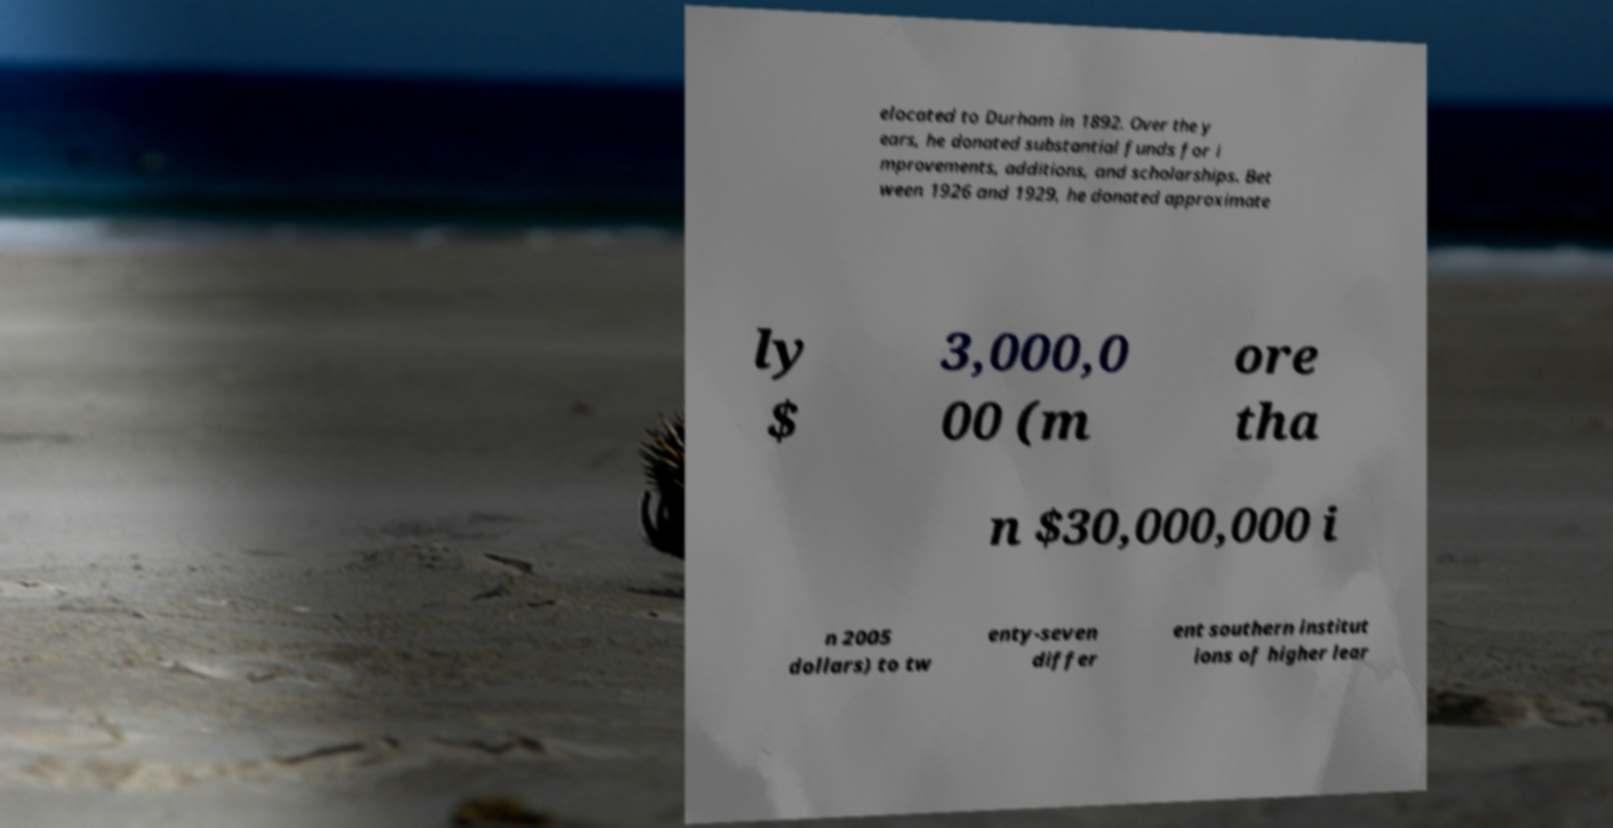I need the written content from this picture converted into text. Can you do that? elocated to Durham in 1892. Over the y ears, he donated substantial funds for i mprovements, additions, and scholarships. Bet ween 1926 and 1929, he donated approximate ly $ 3,000,0 00 (m ore tha n $30,000,000 i n 2005 dollars) to tw enty-seven differ ent southern institut ions of higher lear 